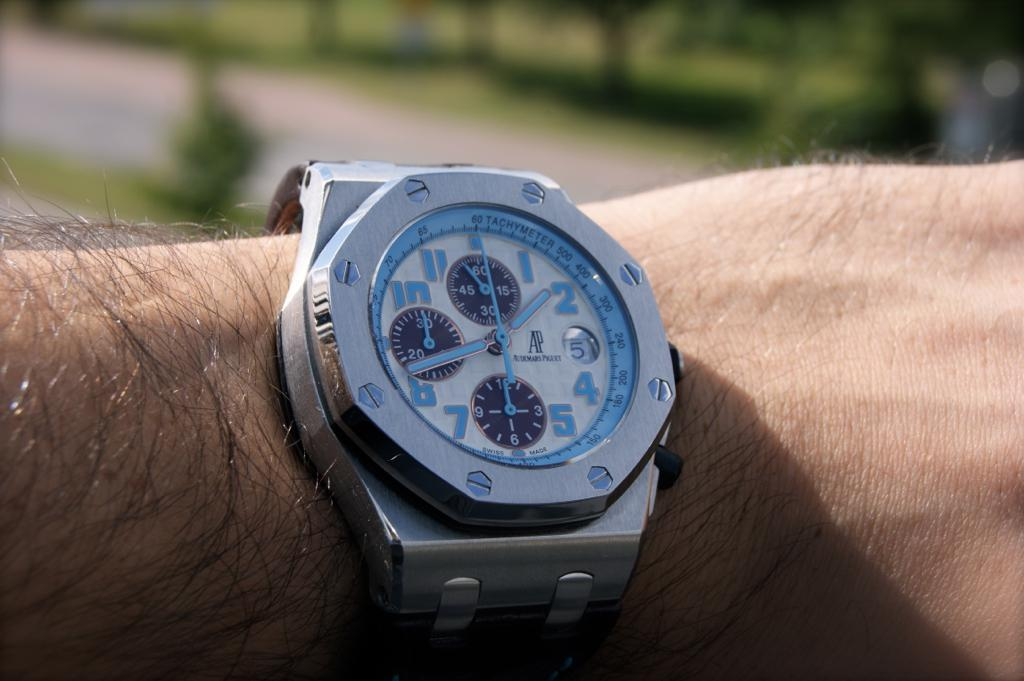<image>
Give a short and clear explanation of the subsequent image. An AP brand watch has blue numbers and hands. 